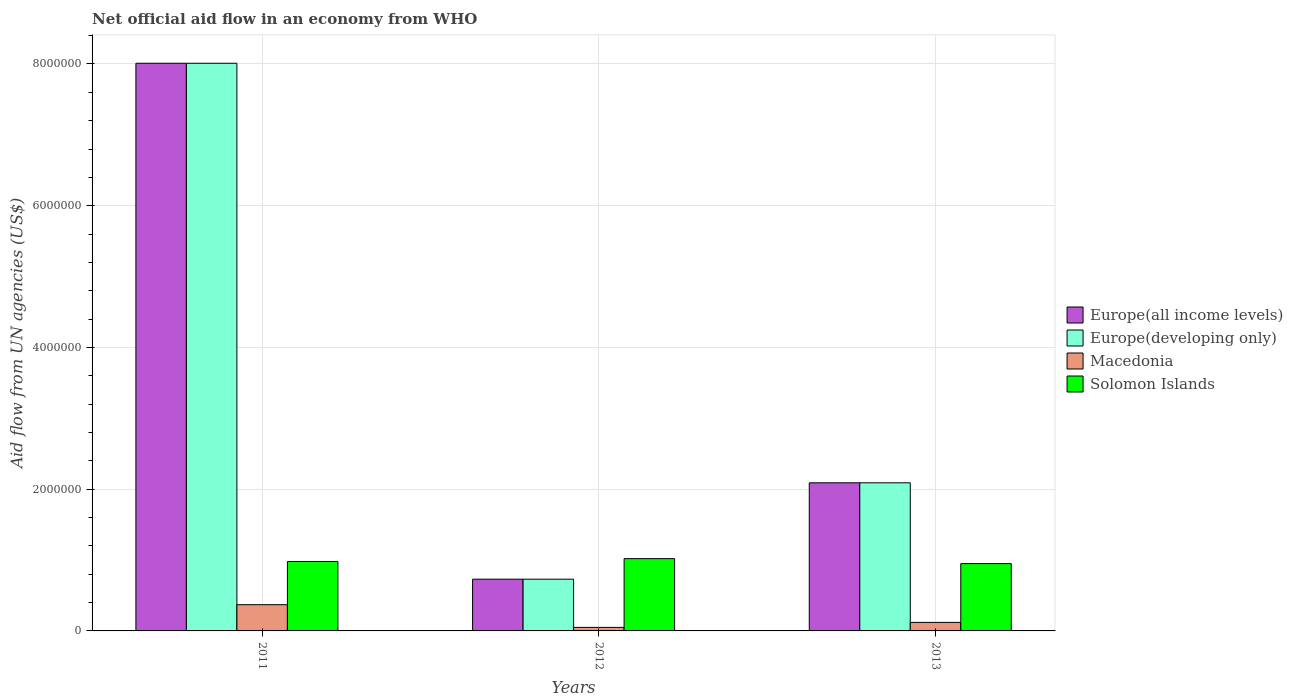How many different coloured bars are there?
Provide a short and direct response. 4. How many bars are there on the 3rd tick from the left?
Your response must be concise. 4. In how many cases, is the number of bars for a given year not equal to the number of legend labels?
Make the answer very short. 0. What is the net official aid flow in Macedonia in 2013?
Your response must be concise. 1.20e+05. Across all years, what is the maximum net official aid flow in Europe(all income levels)?
Ensure brevity in your answer.  8.01e+06. In which year was the net official aid flow in Solomon Islands maximum?
Keep it short and to the point. 2012. What is the total net official aid flow in Macedonia in the graph?
Offer a terse response. 5.40e+05. What is the difference between the net official aid flow in Europe(developing only) in 2012 and that in 2013?
Offer a terse response. -1.36e+06. What is the difference between the net official aid flow in Europe(developing only) in 2012 and the net official aid flow in Solomon Islands in 2013?
Give a very brief answer. -2.20e+05. What is the average net official aid flow in Europe(all income levels) per year?
Provide a succinct answer. 3.61e+06. In the year 2012, what is the difference between the net official aid flow in Macedonia and net official aid flow in Europe(developing only)?
Keep it short and to the point. -6.80e+05. What is the ratio of the net official aid flow in Europe(developing only) in 2011 to that in 2013?
Your answer should be very brief. 3.83. Is the net official aid flow in Macedonia in 2012 less than that in 2013?
Ensure brevity in your answer.  Yes. What is the difference between the highest and the lowest net official aid flow in Macedonia?
Offer a terse response. 3.20e+05. In how many years, is the net official aid flow in Europe(developing only) greater than the average net official aid flow in Europe(developing only) taken over all years?
Ensure brevity in your answer.  1. What does the 2nd bar from the left in 2013 represents?
Make the answer very short. Europe(developing only). What does the 2nd bar from the right in 2013 represents?
Your answer should be compact. Macedonia. What is the difference between two consecutive major ticks on the Y-axis?
Your response must be concise. 2.00e+06. Does the graph contain grids?
Ensure brevity in your answer.  Yes. How many legend labels are there?
Give a very brief answer. 4. What is the title of the graph?
Provide a succinct answer. Net official aid flow in an economy from WHO. What is the label or title of the X-axis?
Your answer should be very brief. Years. What is the label or title of the Y-axis?
Give a very brief answer. Aid flow from UN agencies (US$). What is the Aid flow from UN agencies (US$) in Europe(all income levels) in 2011?
Offer a very short reply. 8.01e+06. What is the Aid flow from UN agencies (US$) of Europe(developing only) in 2011?
Offer a very short reply. 8.01e+06. What is the Aid flow from UN agencies (US$) of Solomon Islands in 2011?
Your answer should be compact. 9.80e+05. What is the Aid flow from UN agencies (US$) in Europe(all income levels) in 2012?
Your answer should be compact. 7.30e+05. What is the Aid flow from UN agencies (US$) in Europe(developing only) in 2012?
Your answer should be compact. 7.30e+05. What is the Aid flow from UN agencies (US$) of Solomon Islands in 2012?
Ensure brevity in your answer.  1.02e+06. What is the Aid flow from UN agencies (US$) in Europe(all income levels) in 2013?
Offer a terse response. 2.09e+06. What is the Aid flow from UN agencies (US$) of Europe(developing only) in 2013?
Offer a terse response. 2.09e+06. What is the Aid flow from UN agencies (US$) of Macedonia in 2013?
Provide a short and direct response. 1.20e+05. What is the Aid flow from UN agencies (US$) of Solomon Islands in 2013?
Your answer should be very brief. 9.50e+05. Across all years, what is the maximum Aid flow from UN agencies (US$) in Europe(all income levels)?
Provide a succinct answer. 8.01e+06. Across all years, what is the maximum Aid flow from UN agencies (US$) of Europe(developing only)?
Give a very brief answer. 8.01e+06. Across all years, what is the maximum Aid flow from UN agencies (US$) in Solomon Islands?
Provide a short and direct response. 1.02e+06. Across all years, what is the minimum Aid flow from UN agencies (US$) in Europe(all income levels)?
Provide a succinct answer. 7.30e+05. Across all years, what is the minimum Aid flow from UN agencies (US$) in Europe(developing only)?
Provide a short and direct response. 7.30e+05. Across all years, what is the minimum Aid flow from UN agencies (US$) in Macedonia?
Provide a short and direct response. 5.00e+04. Across all years, what is the minimum Aid flow from UN agencies (US$) of Solomon Islands?
Give a very brief answer. 9.50e+05. What is the total Aid flow from UN agencies (US$) of Europe(all income levels) in the graph?
Offer a terse response. 1.08e+07. What is the total Aid flow from UN agencies (US$) in Europe(developing only) in the graph?
Keep it short and to the point. 1.08e+07. What is the total Aid flow from UN agencies (US$) of Macedonia in the graph?
Provide a succinct answer. 5.40e+05. What is the total Aid flow from UN agencies (US$) in Solomon Islands in the graph?
Keep it short and to the point. 2.95e+06. What is the difference between the Aid flow from UN agencies (US$) in Europe(all income levels) in 2011 and that in 2012?
Give a very brief answer. 7.28e+06. What is the difference between the Aid flow from UN agencies (US$) in Europe(developing only) in 2011 and that in 2012?
Your response must be concise. 7.28e+06. What is the difference between the Aid flow from UN agencies (US$) of Europe(all income levels) in 2011 and that in 2013?
Give a very brief answer. 5.92e+06. What is the difference between the Aid flow from UN agencies (US$) in Europe(developing only) in 2011 and that in 2013?
Your response must be concise. 5.92e+06. What is the difference between the Aid flow from UN agencies (US$) of Solomon Islands in 2011 and that in 2013?
Your answer should be very brief. 3.00e+04. What is the difference between the Aid flow from UN agencies (US$) of Europe(all income levels) in 2012 and that in 2013?
Ensure brevity in your answer.  -1.36e+06. What is the difference between the Aid flow from UN agencies (US$) of Europe(developing only) in 2012 and that in 2013?
Make the answer very short. -1.36e+06. What is the difference between the Aid flow from UN agencies (US$) of Solomon Islands in 2012 and that in 2013?
Offer a very short reply. 7.00e+04. What is the difference between the Aid flow from UN agencies (US$) of Europe(all income levels) in 2011 and the Aid flow from UN agencies (US$) of Europe(developing only) in 2012?
Your answer should be compact. 7.28e+06. What is the difference between the Aid flow from UN agencies (US$) of Europe(all income levels) in 2011 and the Aid flow from UN agencies (US$) of Macedonia in 2012?
Give a very brief answer. 7.96e+06. What is the difference between the Aid flow from UN agencies (US$) in Europe(all income levels) in 2011 and the Aid flow from UN agencies (US$) in Solomon Islands in 2012?
Make the answer very short. 6.99e+06. What is the difference between the Aid flow from UN agencies (US$) of Europe(developing only) in 2011 and the Aid flow from UN agencies (US$) of Macedonia in 2012?
Make the answer very short. 7.96e+06. What is the difference between the Aid flow from UN agencies (US$) of Europe(developing only) in 2011 and the Aid flow from UN agencies (US$) of Solomon Islands in 2012?
Keep it short and to the point. 6.99e+06. What is the difference between the Aid flow from UN agencies (US$) of Macedonia in 2011 and the Aid flow from UN agencies (US$) of Solomon Islands in 2012?
Provide a succinct answer. -6.50e+05. What is the difference between the Aid flow from UN agencies (US$) of Europe(all income levels) in 2011 and the Aid flow from UN agencies (US$) of Europe(developing only) in 2013?
Provide a short and direct response. 5.92e+06. What is the difference between the Aid flow from UN agencies (US$) in Europe(all income levels) in 2011 and the Aid flow from UN agencies (US$) in Macedonia in 2013?
Offer a very short reply. 7.89e+06. What is the difference between the Aid flow from UN agencies (US$) in Europe(all income levels) in 2011 and the Aid flow from UN agencies (US$) in Solomon Islands in 2013?
Provide a succinct answer. 7.06e+06. What is the difference between the Aid flow from UN agencies (US$) of Europe(developing only) in 2011 and the Aid flow from UN agencies (US$) of Macedonia in 2013?
Make the answer very short. 7.89e+06. What is the difference between the Aid flow from UN agencies (US$) in Europe(developing only) in 2011 and the Aid flow from UN agencies (US$) in Solomon Islands in 2013?
Give a very brief answer. 7.06e+06. What is the difference between the Aid flow from UN agencies (US$) in Macedonia in 2011 and the Aid flow from UN agencies (US$) in Solomon Islands in 2013?
Your answer should be very brief. -5.80e+05. What is the difference between the Aid flow from UN agencies (US$) in Europe(all income levels) in 2012 and the Aid flow from UN agencies (US$) in Europe(developing only) in 2013?
Your answer should be very brief. -1.36e+06. What is the difference between the Aid flow from UN agencies (US$) of Europe(all income levels) in 2012 and the Aid flow from UN agencies (US$) of Solomon Islands in 2013?
Ensure brevity in your answer.  -2.20e+05. What is the difference between the Aid flow from UN agencies (US$) of Macedonia in 2012 and the Aid flow from UN agencies (US$) of Solomon Islands in 2013?
Your response must be concise. -9.00e+05. What is the average Aid flow from UN agencies (US$) of Europe(all income levels) per year?
Your answer should be very brief. 3.61e+06. What is the average Aid flow from UN agencies (US$) in Europe(developing only) per year?
Keep it short and to the point. 3.61e+06. What is the average Aid flow from UN agencies (US$) in Macedonia per year?
Your answer should be very brief. 1.80e+05. What is the average Aid flow from UN agencies (US$) of Solomon Islands per year?
Your answer should be compact. 9.83e+05. In the year 2011, what is the difference between the Aid flow from UN agencies (US$) of Europe(all income levels) and Aid flow from UN agencies (US$) of Macedonia?
Offer a terse response. 7.64e+06. In the year 2011, what is the difference between the Aid flow from UN agencies (US$) of Europe(all income levels) and Aid flow from UN agencies (US$) of Solomon Islands?
Offer a very short reply. 7.03e+06. In the year 2011, what is the difference between the Aid flow from UN agencies (US$) of Europe(developing only) and Aid flow from UN agencies (US$) of Macedonia?
Your response must be concise. 7.64e+06. In the year 2011, what is the difference between the Aid flow from UN agencies (US$) in Europe(developing only) and Aid flow from UN agencies (US$) in Solomon Islands?
Your answer should be very brief. 7.03e+06. In the year 2011, what is the difference between the Aid flow from UN agencies (US$) in Macedonia and Aid flow from UN agencies (US$) in Solomon Islands?
Offer a very short reply. -6.10e+05. In the year 2012, what is the difference between the Aid flow from UN agencies (US$) of Europe(all income levels) and Aid flow from UN agencies (US$) of Macedonia?
Give a very brief answer. 6.80e+05. In the year 2012, what is the difference between the Aid flow from UN agencies (US$) in Europe(developing only) and Aid flow from UN agencies (US$) in Macedonia?
Give a very brief answer. 6.80e+05. In the year 2012, what is the difference between the Aid flow from UN agencies (US$) of Macedonia and Aid flow from UN agencies (US$) of Solomon Islands?
Give a very brief answer. -9.70e+05. In the year 2013, what is the difference between the Aid flow from UN agencies (US$) in Europe(all income levels) and Aid flow from UN agencies (US$) in Europe(developing only)?
Ensure brevity in your answer.  0. In the year 2013, what is the difference between the Aid flow from UN agencies (US$) of Europe(all income levels) and Aid flow from UN agencies (US$) of Macedonia?
Your response must be concise. 1.97e+06. In the year 2013, what is the difference between the Aid flow from UN agencies (US$) of Europe(all income levels) and Aid flow from UN agencies (US$) of Solomon Islands?
Provide a succinct answer. 1.14e+06. In the year 2013, what is the difference between the Aid flow from UN agencies (US$) in Europe(developing only) and Aid flow from UN agencies (US$) in Macedonia?
Ensure brevity in your answer.  1.97e+06. In the year 2013, what is the difference between the Aid flow from UN agencies (US$) of Europe(developing only) and Aid flow from UN agencies (US$) of Solomon Islands?
Provide a short and direct response. 1.14e+06. In the year 2013, what is the difference between the Aid flow from UN agencies (US$) of Macedonia and Aid flow from UN agencies (US$) of Solomon Islands?
Give a very brief answer. -8.30e+05. What is the ratio of the Aid flow from UN agencies (US$) of Europe(all income levels) in 2011 to that in 2012?
Provide a short and direct response. 10.97. What is the ratio of the Aid flow from UN agencies (US$) in Europe(developing only) in 2011 to that in 2012?
Provide a short and direct response. 10.97. What is the ratio of the Aid flow from UN agencies (US$) in Solomon Islands in 2011 to that in 2012?
Give a very brief answer. 0.96. What is the ratio of the Aid flow from UN agencies (US$) of Europe(all income levels) in 2011 to that in 2013?
Your response must be concise. 3.83. What is the ratio of the Aid flow from UN agencies (US$) of Europe(developing only) in 2011 to that in 2013?
Provide a succinct answer. 3.83. What is the ratio of the Aid flow from UN agencies (US$) in Macedonia in 2011 to that in 2013?
Provide a short and direct response. 3.08. What is the ratio of the Aid flow from UN agencies (US$) of Solomon Islands in 2011 to that in 2013?
Your answer should be compact. 1.03. What is the ratio of the Aid flow from UN agencies (US$) in Europe(all income levels) in 2012 to that in 2013?
Provide a succinct answer. 0.35. What is the ratio of the Aid flow from UN agencies (US$) in Europe(developing only) in 2012 to that in 2013?
Offer a terse response. 0.35. What is the ratio of the Aid flow from UN agencies (US$) in Macedonia in 2012 to that in 2013?
Offer a very short reply. 0.42. What is the ratio of the Aid flow from UN agencies (US$) in Solomon Islands in 2012 to that in 2013?
Provide a succinct answer. 1.07. What is the difference between the highest and the second highest Aid flow from UN agencies (US$) in Europe(all income levels)?
Your answer should be very brief. 5.92e+06. What is the difference between the highest and the second highest Aid flow from UN agencies (US$) in Europe(developing only)?
Make the answer very short. 5.92e+06. What is the difference between the highest and the second highest Aid flow from UN agencies (US$) in Solomon Islands?
Your answer should be very brief. 4.00e+04. What is the difference between the highest and the lowest Aid flow from UN agencies (US$) in Europe(all income levels)?
Your response must be concise. 7.28e+06. What is the difference between the highest and the lowest Aid flow from UN agencies (US$) in Europe(developing only)?
Provide a succinct answer. 7.28e+06. 